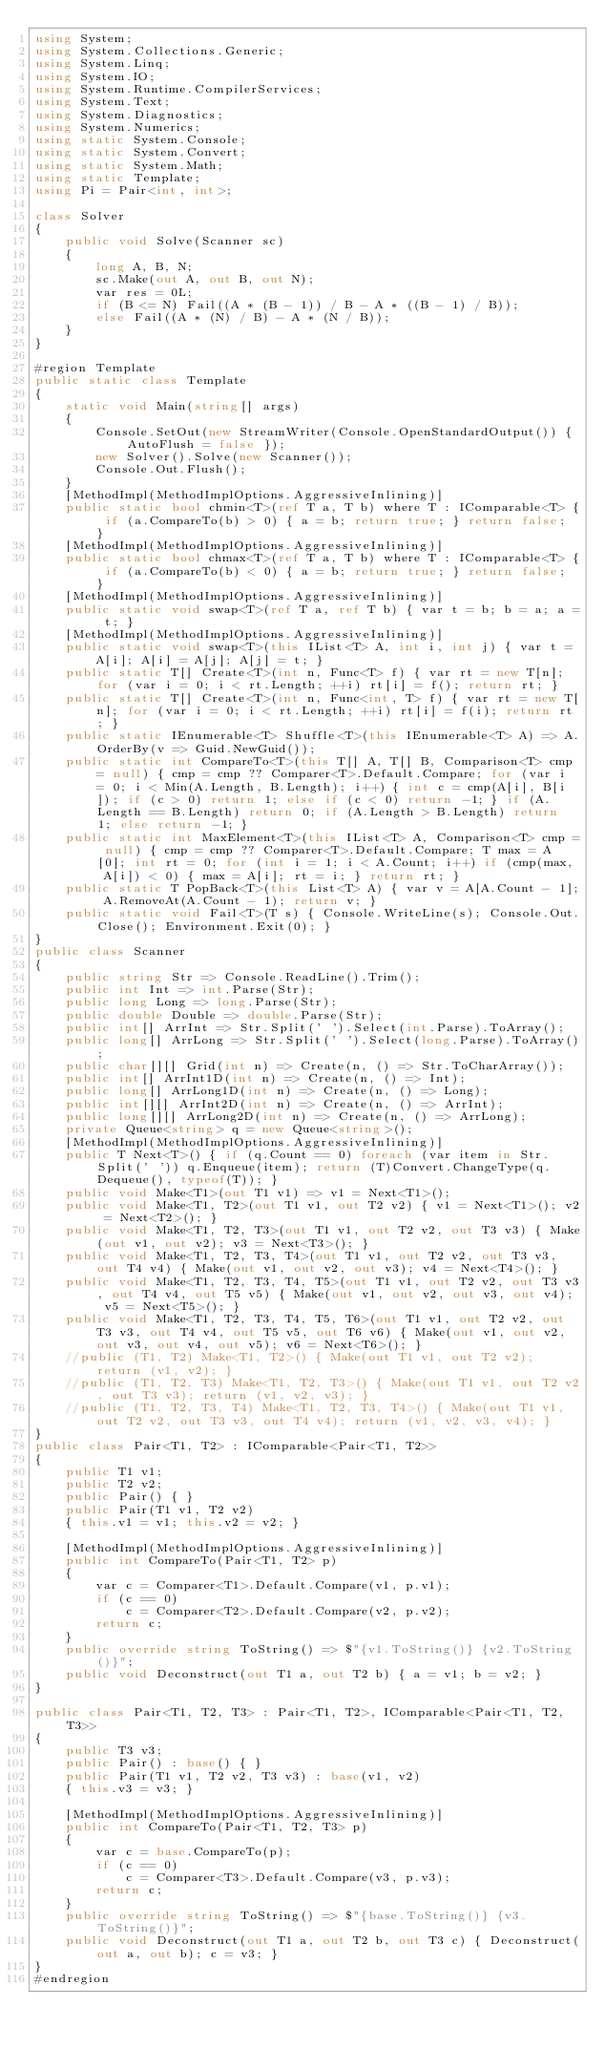Convert code to text. <code><loc_0><loc_0><loc_500><loc_500><_C#_>using System;
using System.Collections.Generic;
using System.Linq;
using System.IO;
using System.Runtime.CompilerServices;
using System.Text;
using System.Diagnostics;
using System.Numerics;
using static System.Console;
using static System.Convert;
using static System.Math;
using static Template;
using Pi = Pair<int, int>;

class Solver
{
    public void Solve(Scanner sc)
    {
        long A, B, N;
        sc.Make(out A, out B, out N);
        var res = 0L;
        if (B <= N) Fail((A * (B - 1)) / B - A * ((B - 1) / B));
        else Fail((A * (N) / B) - A * (N / B));
    }
}

#region Template
public static class Template
{
    static void Main(string[] args)
    {
        Console.SetOut(new StreamWriter(Console.OpenStandardOutput()) { AutoFlush = false });
        new Solver().Solve(new Scanner());
        Console.Out.Flush();
    }
    [MethodImpl(MethodImplOptions.AggressiveInlining)]
    public static bool chmin<T>(ref T a, T b) where T : IComparable<T> { if (a.CompareTo(b) > 0) { a = b; return true; } return false; }
    [MethodImpl(MethodImplOptions.AggressiveInlining)]
    public static bool chmax<T>(ref T a, T b) where T : IComparable<T> { if (a.CompareTo(b) < 0) { a = b; return true; } return false; }
    [MethodImpl(MethodImplOptions.AggressiveInlining)]
    public static void swap<T>(ref T a, ref T b) { var t = b; b = a; a = t; }
    [MethodImpl(MethodImplOptions.AggressiveInlining)]
    public static void swap<T>(this IList<T> A, int i, int j) { var t = A[i]; A[i] = A[j]; A[j] = t; }
    public static T[] Create<T>(int n, Func<T> f) { var rt = new T[n]; for (var i = 0; i < rt.Length; ++i) rt[i] = f(); return rt; }
    public static T[] Create<T>(int n, Func<int, T> f) { var rt = new T[n]; for (var i = 0; i < rt.Length; ++i) rt[i] = f(i); return rt; }
    public static IEnumerable<T> Shuffle<T>(this IEnumerable<T> A) => A.OrderBy(v => Guid.NewGuid());
    public static int CompareTo<T>(this T[] A, T[] B, Comparison<T> cmp = null) { cmp = cmp ?? Comparer<T>.Default.Compare; for (var i = 0; i < Min(A.Length, B.Length); i++) { int c = cmp(A[i], B[i]); if (c > 0) return 1; else if (c < 0) return -1; } if (A.Length == B.Length) return 0; if (A.Length > B.Length) return 1; else return -1; }
    public static int MaxElement<T>(this IList<T> A, Comparison<T> cmp = null) { cmp = cmp ?? Comparer<T>.Default.Compare; T max = A[0]; int rt = 0; for (int i = 1; i < A.Count; i++) if (cmp(max, A[i]) < 0) { max = A[i]; rt = i; } return rt; }
    public static T PopBack<T>(this List<T> A) { var v = A[A.Count - 1]; A.RemoveAt(A.Count - 1); return v; }
    public static void Fail<T>(T s) { Console.WriteLine(s); Console.Out.Close(); Environment.Exit(0); }
}
public class Scanner
{
    public string Str => Console.ReadLine().Trim();
    public int Int => int.Parse(Str);
    public long Long => long.Parse(Str);
    public double Double => double.Parse(Str);
    public int[] ArrInt => Str.Split(' ').Select(int.Parse).ToArray();
    public long[] ArrLong => Str.Split(' ').Select(long.Parse).ToArray();
    public char[][] Grid(int n) => Create(n, () => Str.ToCharArray());
    public int[] ArrInt1D(int n) => Create(n, () => Int);
    public long[] ArrLong1D(int n) => Create(n, () => Long);
    public int[][] ArrInt2D(int n) => Create(n, () => ArrInt);
    public long[][] ArrLong2D(int n) => Create(n, () => ArrLong);
    private Queue<string> q = new Queue<string>();
    [MethodImpl(MethodImplOptions.AggressiveInlining)]
    public T Next<T>() { if (q.Count == 0) foreach (var item in Str.Split(' ')) q.Enqueue(item); return (T)Convert.ChangeType(q.Dequeue(), typeof(T)); }
    public void Make<T1>(out T1 v1) => v1 = Next<T1>();
    public void Make<T1, T2>(out T1 v1, out T2 v2) { v1 = Next<T1>(); v2 = Next<T2>(); }
    public void Make<T1, T2, T3>(out T1 v1, out T2 v2, out T3 v3) { Make(out v1, out v2); v3 = Next<T3>(); }
    public void Make<T1, T2, T3, T4>(out T1 v1, out T2 v2, out T3 v3, out T4 v4) { Make(out v1, out v2, out v3); v4 = Next<T4>(); }
    public void Make<T1, T2, T3, T4, T5>(out T1 v1, out T2 v2, out T3 v3, out T4 v4, out T5 v5) { Make(out v1, out v2, out v3, out v4); v5 = Next<T5>(); }
    public void Make<T1, T2, T3, T4, T5, T6>(out T1 v1, out T2 v2, out T3 v3, out T4 v4, out T5 v5, out T6 v6) { Make(out v1, out v2, out v3, out v4, out v5); v6 = Next<T6>(); }
    //public (T1, T2) Make<T1, T2>() { Make(out T1 v1, out T2 v2); return (v1, v2); }
    //public (T1, T2, T3) Make<T1, T2, T3>() { Make(out T1 v1, out T2 v2, out T3 v3); return (v1, v2, v3); }
    //public (T1, T2, T3, T4) Make<T1, T2, T3, T4>() { Make(out T1 v1, out T2 v2, out T3 v3, out T4 v4); return (v1, v2, v3, v4); }
}
public class Pair<T1, T2> : IComparable<Pair<T1, T2>>
{
    public T1 v1;
    public T2 v2;
    public Pair() { }
    public Pair(T1 v1, T2 v2)
    { this.v1 = v1; this.v2 = v2; }

    [MethodImpl(MethodImplOptions.AggressiveInlining)]
    public int CompareTo(Pair<T1, T2> p)
    {
        var c = Comparer<T1>.Default.Compare(v1, p.v1);
        if (c == 0)
            c = Comparer<T2>.Default.Compare(v2, p.v2);
        return c;
    }
    public override string ToString() => $"{v1.ToString()} {v2.ToString()}";
    public void Deconstruct(out T1 a, out T2 b) { a = v1; b = v2; }
}

public class Pair<T1, T2, T3> : Pair<T1, T2>, IComparable<Pair<T1, T2, T3>>
{
    public T3 v3;
    public Pair() : base() { }
    public Pair(T1 v1, T2 v2, T3 v3) : base(v1, v2)
    { this.v3 = v3; }

    [MethodImpl(MethodImplOptions.AggressiveInlining)]
    public int CompareTo(Pair<T1, T2, T3> p)
    {
        var c = base.CompareTo(p);
        if (c == 0)
            c = Comparer<T3>.Default.Compare(v3, p.v3);
        return c;
    }
    public override string ToString() => $"{base.ToString()} {v3.ToString()}";
    public void Deconstruct(out T1 a, out T2 b, out T3 c) { Deconstruct(out a, out b); c = v3; }
}
#endregion
</code> 